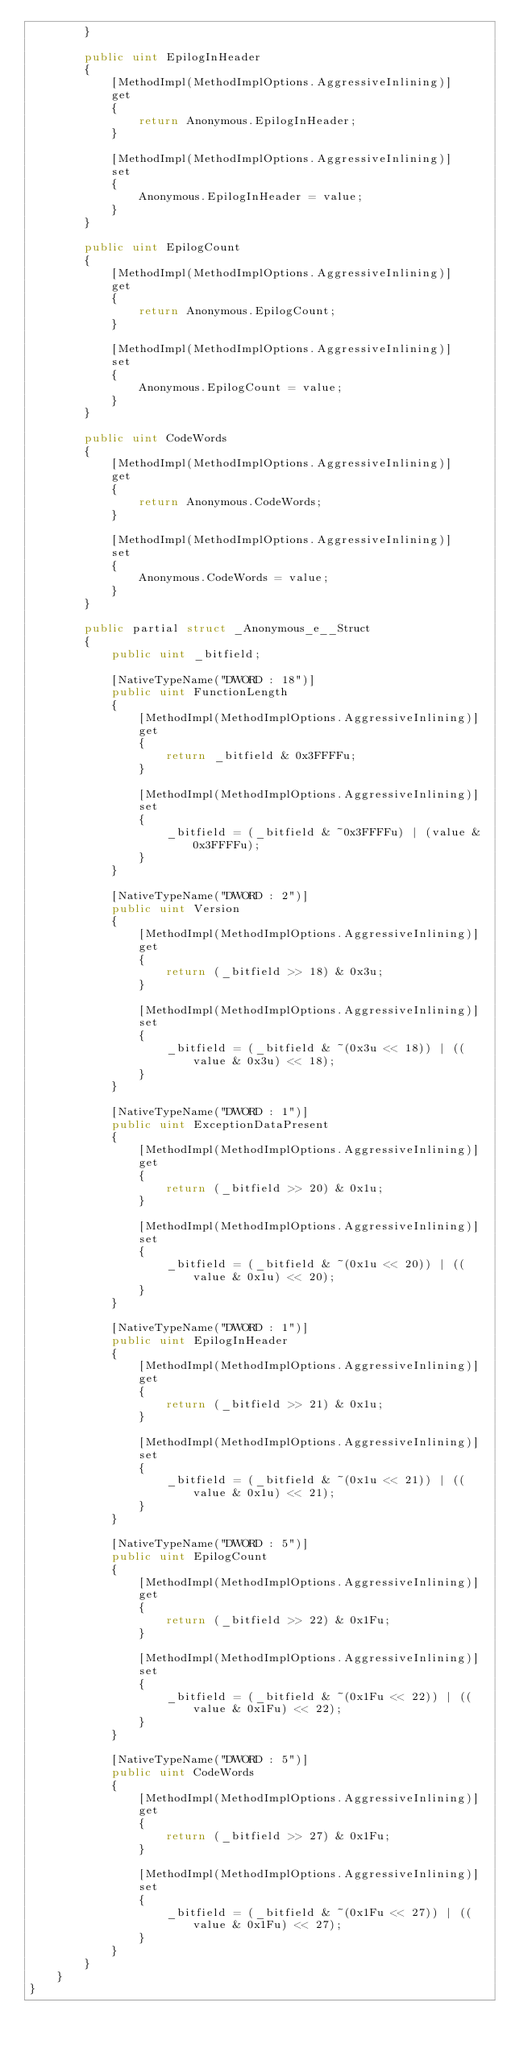Convert code to text. <code><loc_0><loc_0><loc_500><loc_500><_C#_>        }

        public uint EpilogInHeader
        {
            [MethodImpl(MethodImplOptions.AggressiveInlining)]
            get
            {
                return Anonymous.EpilogInHeader;
            }

            [MethodImpl(MethodImplOptions.AggressiveInlining)]
            set
            {
                Anonymous.EpilogInHeader = value;
            }
        }

        public uint EpilogCount
        {
            [MethodImpl(MethodImplOptions.AggressiveInlining)]
            get
            {
                return Anonymous.EpilogCount;
            }

            [MethodImpl(MethodImplOptions.AggressiveInlining)]
            set
            {
                Anonymous.EpilogCount = value;
            }
        }

        public uint CodeWords
        {
            [MethodImpl(MethodImplOptions.AggressiveInlining)]
            get
            {
                return Anonymous.CodeWords;
            }

            [MethodImpl(MethodImplOptions.AggressiveInlining)]
            set
            {
                Anonymous.CodeWords = value;
            }
        }

        public partial struct _Anonymous_e__Struct
        {
            public uint _bitfield;

            [NativeTypeName("DWORD : 18")]
            public uint FunctionLength
            {
                [MethodImpl(MethodImplOptions.AggressiveInlining)]
                get
                {
                    return _bitfield & 0x3FFFFu;
                }

                [MethodImpl(MethodImplOptions.AggressiveInlining)]
                set
                {
                    _bitfield = (_bitfield & ~0x3FFFFu) | (value & 0x3FFFFu);
                }
            }

            [NativeTypeName("DWORD : 2")]
            public uint Version
            {
                [MethodImpl(MethodImplOptions.AggressiveInlining)]
                get
                {
                    return (_bitfield >> 18) & 0x3u;
                }

                [MethodImpl(MethodImplOptions.AggressiveInlining)]
                set
                {
                    _bitfield = (_bitfield & ~(0x3u << 18)) | ((value & 0x3u) << 18);
                }
            }

            [NativeTypeName("DWORD : 1")]
            public uint ExceptionDataPresent
            {
                [MethodImpl(MethodImplOptions.AggressiveInlining)]
                get
                {
                    return (_bitfield >> 20) & 0x1u;
                }

                [MethodImpl(MethodImplOptions.AggressiveInlining)]
                set
                {
                    _bitfield = (_bitfield & ~(0x1u << 20)) | ((value & 0x1u) << 20);
                }
            }

            [NativeTypeName("DWORD : 1")]
            public uint EpilogInHeader
            {
                [MethodImpl(MethodImplOptions.AggressiveInlining)]
                get
                {
                    return (_bitfield >> 21) & 0x1u;
                }

                [MethodImpl(MethodImplOptions.AggressiveInlining)]
                set
                {
                    _bitfield = (_bitfield & ~(0x1u << 21)) | ((value & 0x1u) << 21);
                }
            }

            [NativeTypeName("DWORD : 5")]
            public uint EpilogCount
            {
                [MethodImpl(MethodImplOptions.AggressiveInlining)]
                get
                {
                    return (_bitfield >> 22) & 0x1Fu;
                }

                [MethodImpl(MethodImplOptions.AggressiveInlining)]
                set
                {
                    _bitfield = (_bitfield & ~(0x1Fu << 22)) | ((value & 0x1Fu) << 22);
                }
            }

            [NativeTypeName("DWORD : 5")]
            public uint CodeWords
            {
                [MethodImpl(MethodImplOptions.AggressiveInlining)]
                get
                {
                    return (_bitfield >> 27) & 0x1Fu;
                }

                [MethodImpl(MethodImplOptions.AggressiveInlining)]
                set
                {
                    _bitfield = (_bitfield & ~(0x1Fu << 27)) | ((value & 0x1Fu) << 27);
                }
            }
        }
    }
}
</code> 